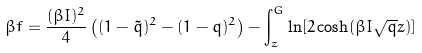Convert formula to latex. <formula><loc_0><loc_0><loc_500><loc_500>\beta f = \frac { ( \beta I ) ^ { 2 } } { 4 } \left ( ( 1 - \tilde { q } ) ^ { 2 } - ( 1 - q ) ^ { 2 } \right ) - \int _ { z } ^ { G } \ln [ 2 \cosh ( \beta I \sqrt { q } z ) ]</formula> 